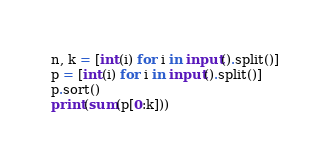<code> <loc_0><loc_0><loc_500><loc_500><_Python_>n, k = [int(i) for i in input().split()]
p = [int(i) for i in input().split()]
p.sort()
print(sum(p[0:k]))</code> 